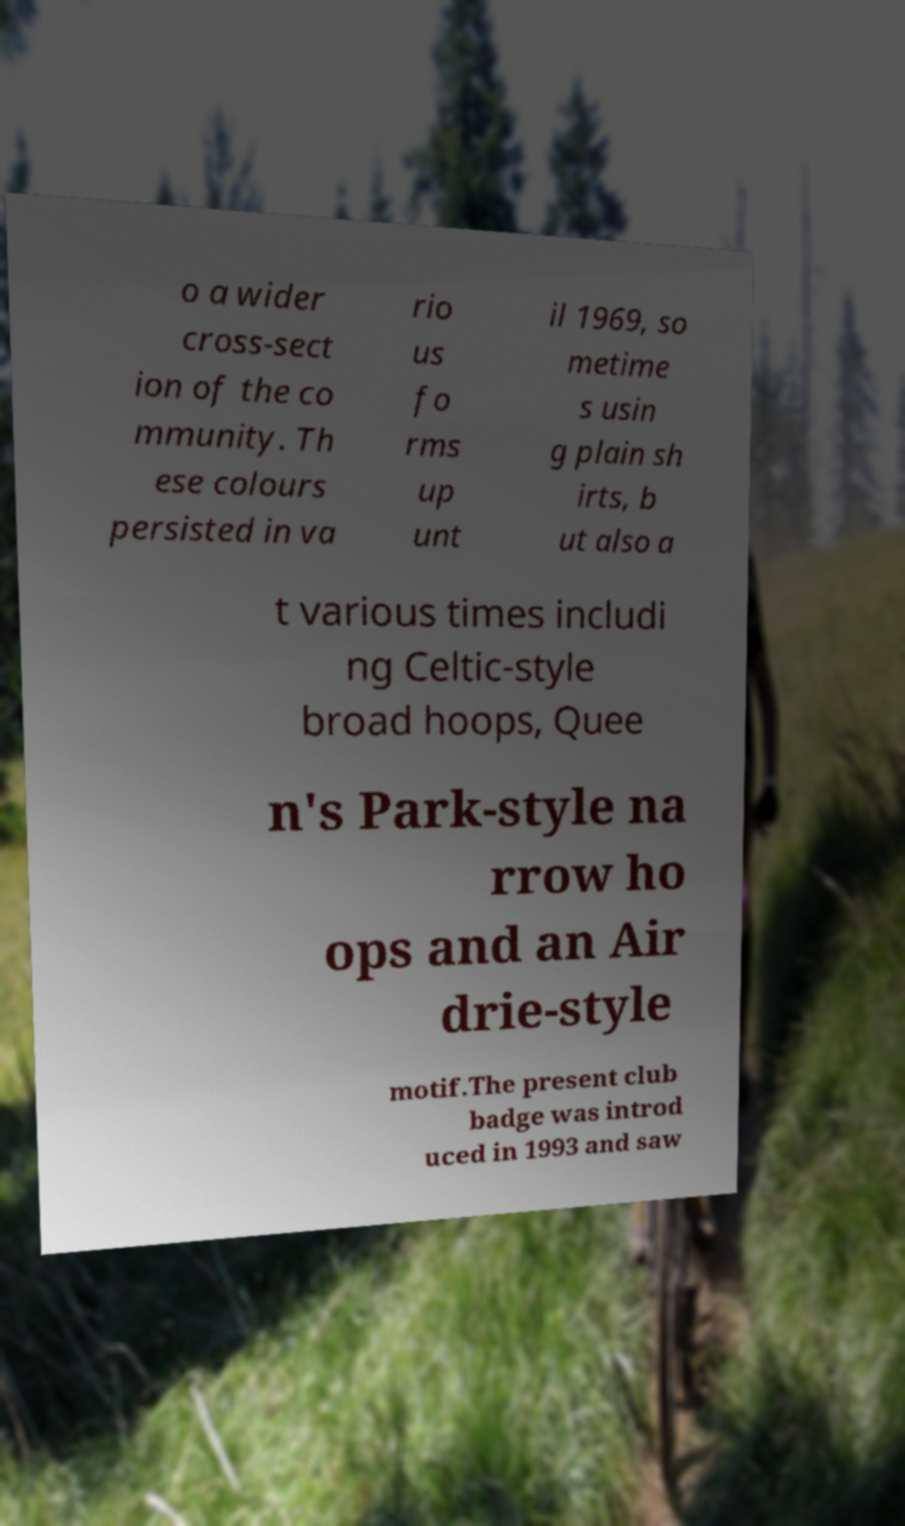I need the written content from this picture converted into text. Can you do that? o a wider cross-sect ion of the co mmunity. Th ese colours persisted in va rio us fo rms up unt il 1969, so metime s usin g plain sh irts, b ut also a t various times includi ng Celtic-style broad hoops, Quee n's Park-style na rrow ho ops and an Air drie-style motif.The present club badge was introd uced in 1993 and saw 